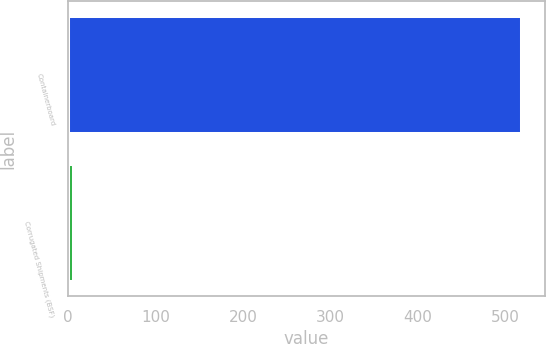<chart> <loc_0><loc_0><loc_500><loc_500><bar_chart><fcel>Containerboard<fcel>Corrugated Shipments (BSF)<nl><fcel>520<fcel>6.5<nl></chart> 